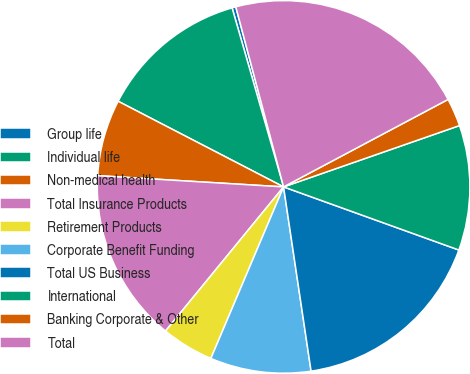<chart> <loc_0><loc_0><loc_500><loc_500><pie_chart><fcel>Group life<fcel>Individual life<fcel>Non-medical health<fcel>Total Insurance Products<fcel>Retirement Products<fcel>Corporate Benefit Funding<fcel>Total US Business<fcel>International<fcel>Banking Corporate & Other<fcel>Total<nl><fcel>0.33%<fcel>12.94%<fcel>6.64%<fcel>15.04%<fcel>4.54%<fcel>8.74%<fcel>17.14%<fcel>10.84%<fcel>2.44%<fcel>21.35%<nl></chart> 